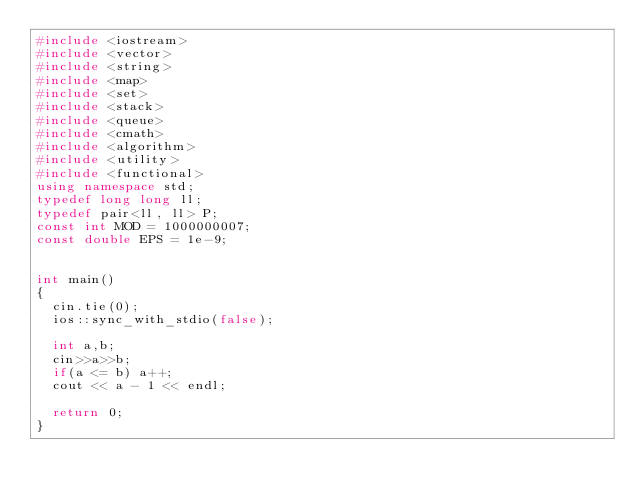Convert code to text. <code><loc_0><loc_0><loc_500><loc_500><_C++_>#include <iostream>
#include <vector>
#include <string>
#include <map>
#include <set>
#include <stack>
#include <queue>
#include <cmath>
#include <algorithm>
#include <utility>
#include <functional>
using namespace std;
typedef long long ll;
typedef pair<ll, ll> P;
const int MOD = 1000000007;
const double EPS = 1e-9;


int main()
{
  cin.tie(0);
  ios::sync_with_stdio(false);

  int a,b;
  cin>>a>>b;
  if(a <= b) a++;
  cout << a - 1 << endl;

  return 0;
}
</code> 